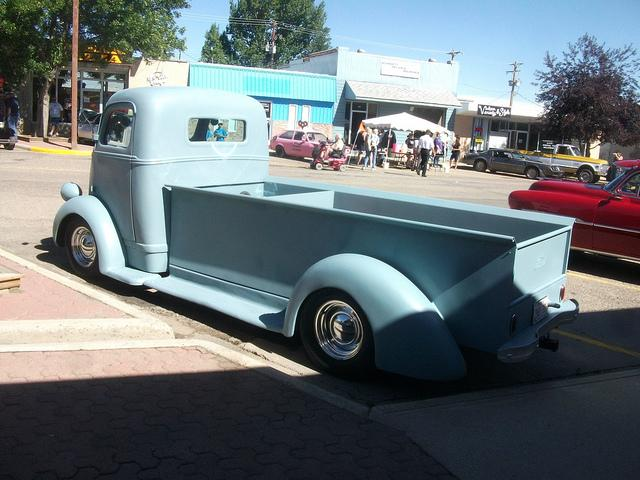What color is the strange old truck? Please explain your reasoning. turquoise. The pale whitefish blue color of this truck could be called turquoise. 